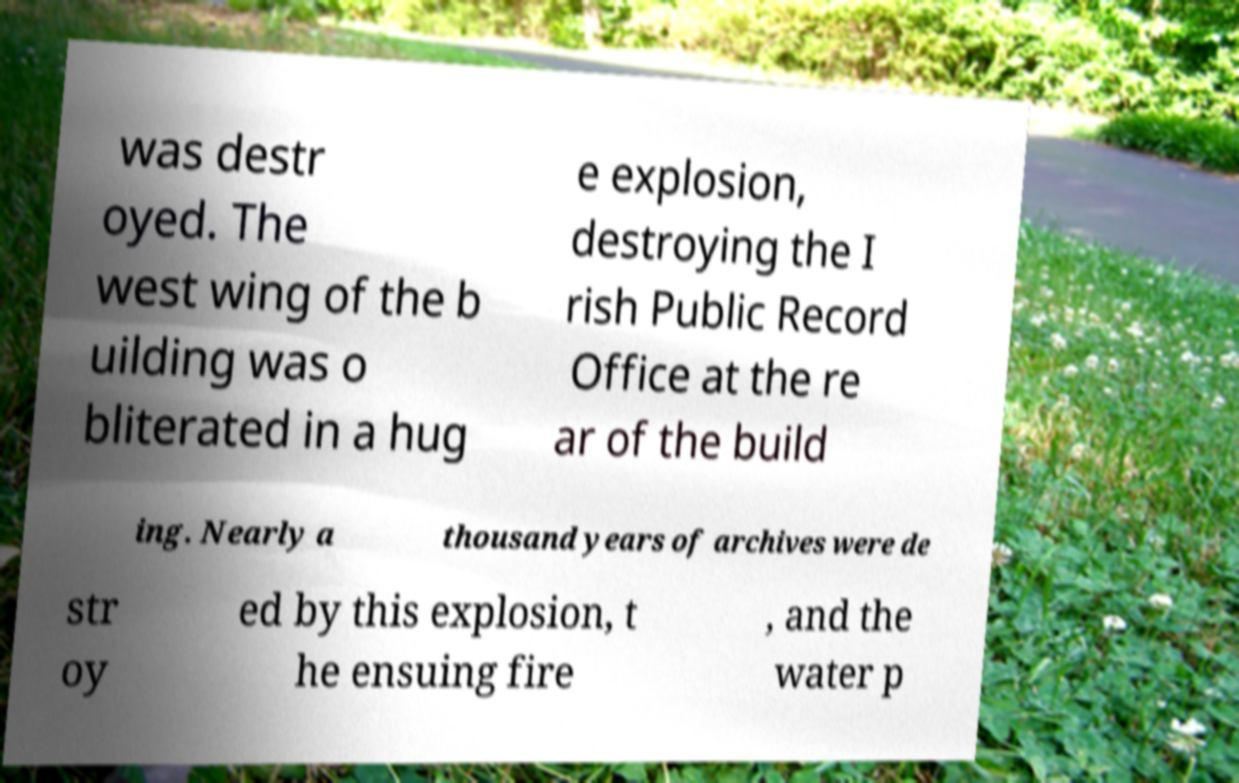Could you extract and type out the text from this image? was destr oyed. The west wing of the b uilding was o bliterated in a hug e explosion, destroying the I rish Public Record Office at the re ar of the build ing. Nearly a thousand years of archives were de str oy ed by this explosion, t he ensuing fire , and the water p 